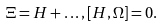Convert formula to latex. <formula><loc_0><loc_0><loc_500><loc_500>\Xi = H + \dots , [ H , \Omega ] = 0 .</formula> 